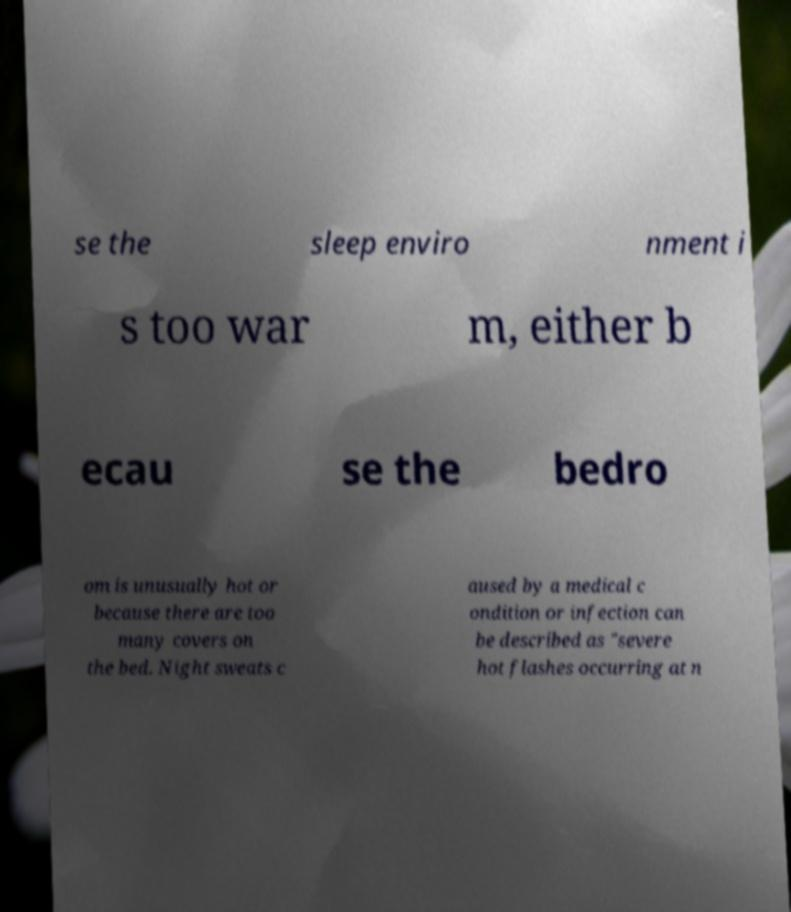Please read and relay the text visible in this image. What does it say? se the sleep enviro nment i s too war m, either b ecau se the bedro om is unusually hot or because there are too many covers on the bed. Night sweats c aused by a medical c ondition or infection can be described as "severe hot flashes occurring at n 